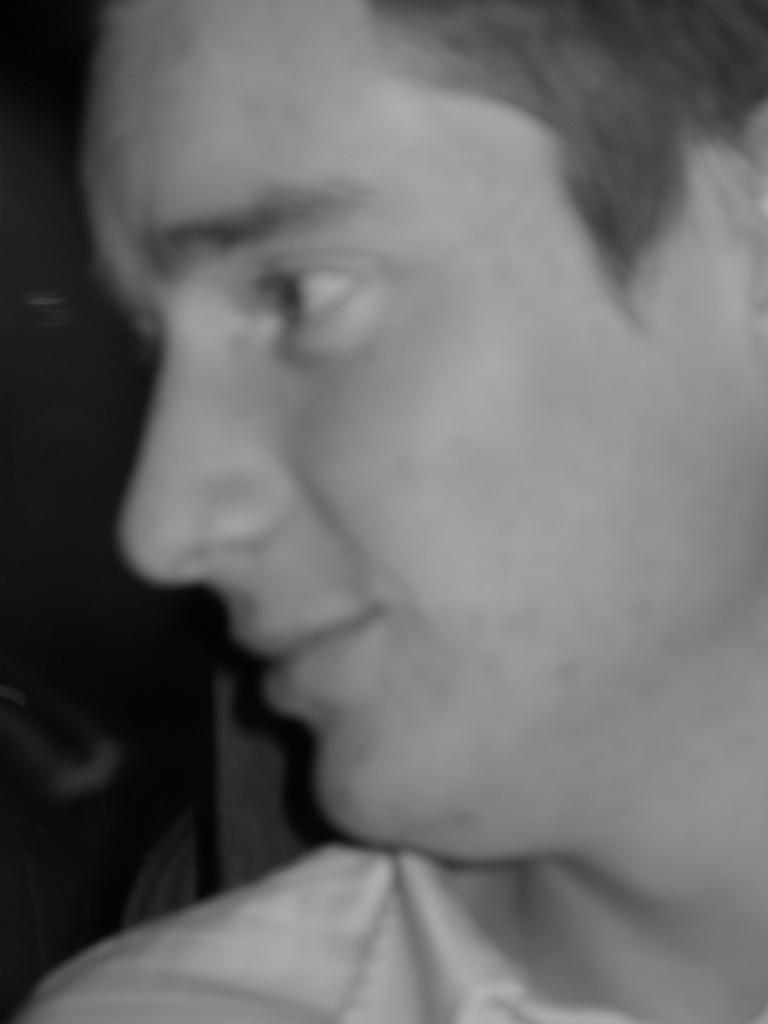What is the color scheme of the picture? The picture is black and white. What is the main subject of the image? There is a face of a person in the picture. What type of cake is being served in the picture? There is no cake present in the picture; it is a black and white image featuring a face of a person. What role does the pump play in the image? There is no pump present in the image; it is a black and white image featuring a face of a person. 